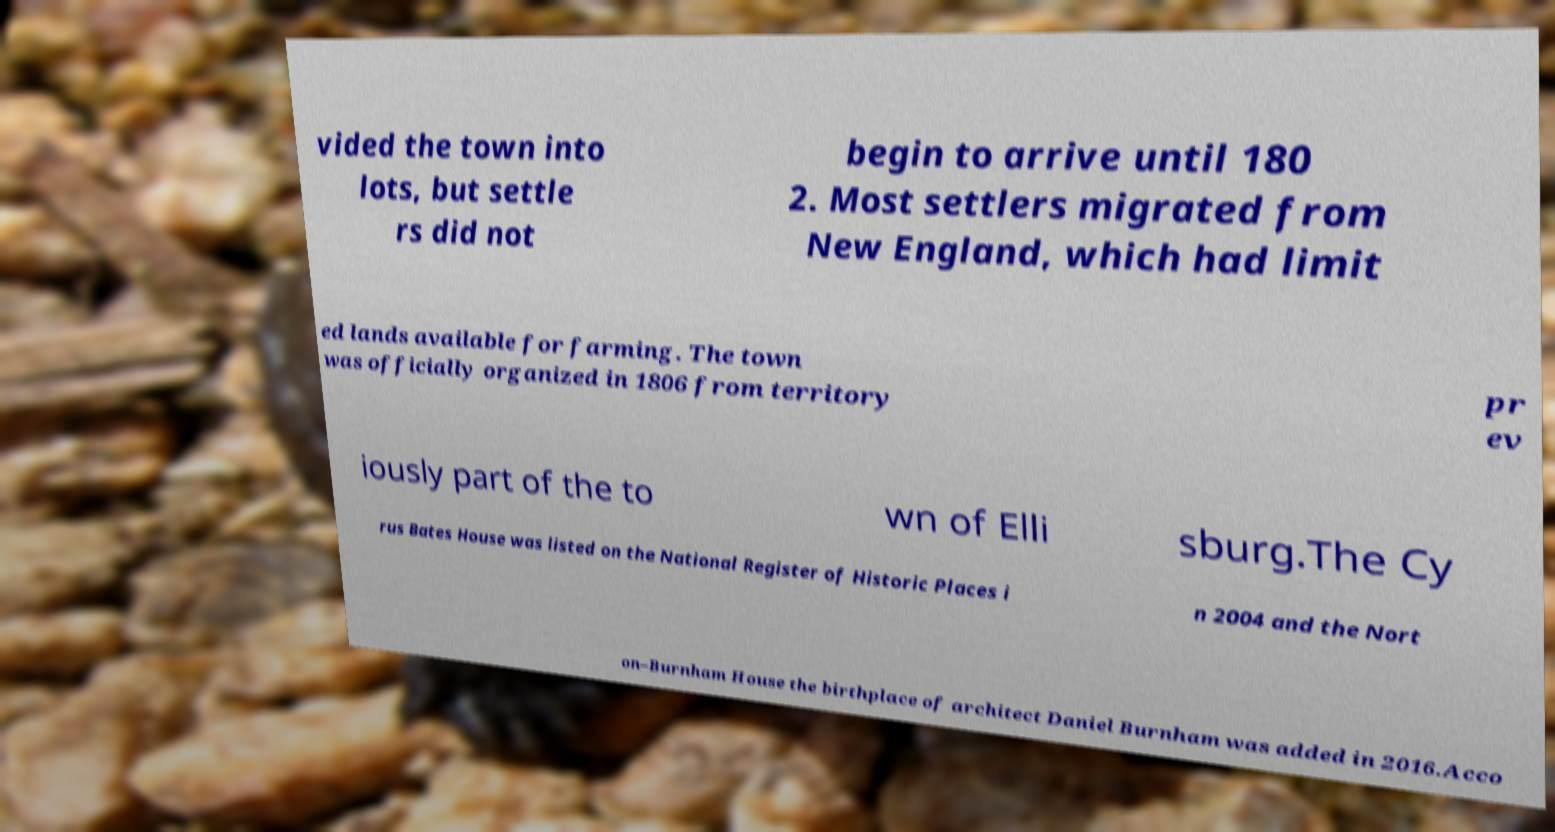What messages or text are displayed in this image? I need them in a readable, typed format. vided the town into lots, but settle rs did not begin to arrive until 180 2. Most settlers migrated from New England, which had limit ed lands available for farming. The town was officially organized in 1806 from territory pr ev iously part of the to wn of Elli sburg.The Cy rus Bates House was listed on the National Register of Historic Places i n 2004 and the Nort on–Burnham House the birthplace of architect Daniel Burnham was added in 2016.Acco 